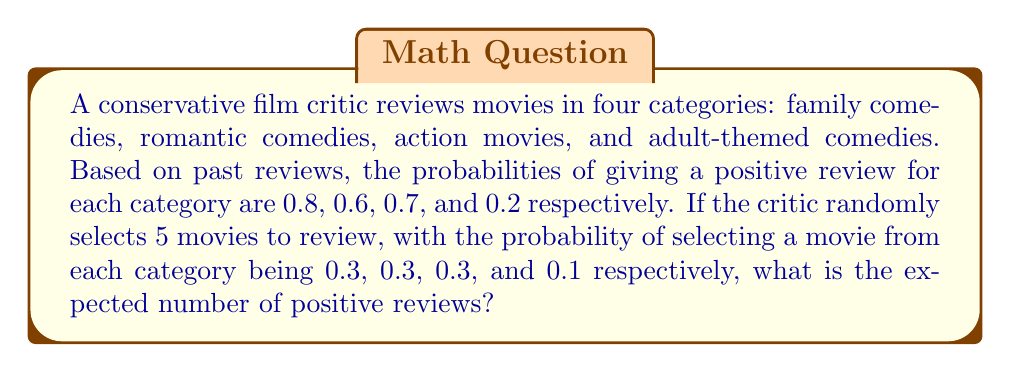Can you solve this math problem? Let's approach this step-by-step using the concept of expected value:

1) First, we need to calculate the overall probability of a positive review for a randomly selected movie. We can do this using the law of total probability:

   $P(\text{positive}) = \sum_{i=1}^{4} P(\text{positive}|\text{category}_i) \cdot P(\text{category}_i)$

   $= 0.8 \cdot 0.3 + 0.6 \cdot 0.3 + 0.7 \cdot 0.3 + 0.2 \cdot 0.1$
   $= 0.24 + 0.18 + 0.21 + 0.02 = 0.65$

2) Now, we can model the number of positive reviews as a binomial random variable $X \sim B(n,p)$, where:
   - $n = 5$ (number of movies reviewed)
   - $p = 0.65$ (probability of a positive review for any given movie)

3) The expected value of a binomial distribution is given by $E[X] = np$

4) Therefore, the expected number of positive reviews is:

   $E[X] = 5 \cdot 0.65 = 3.25$
Answer: 3.25 